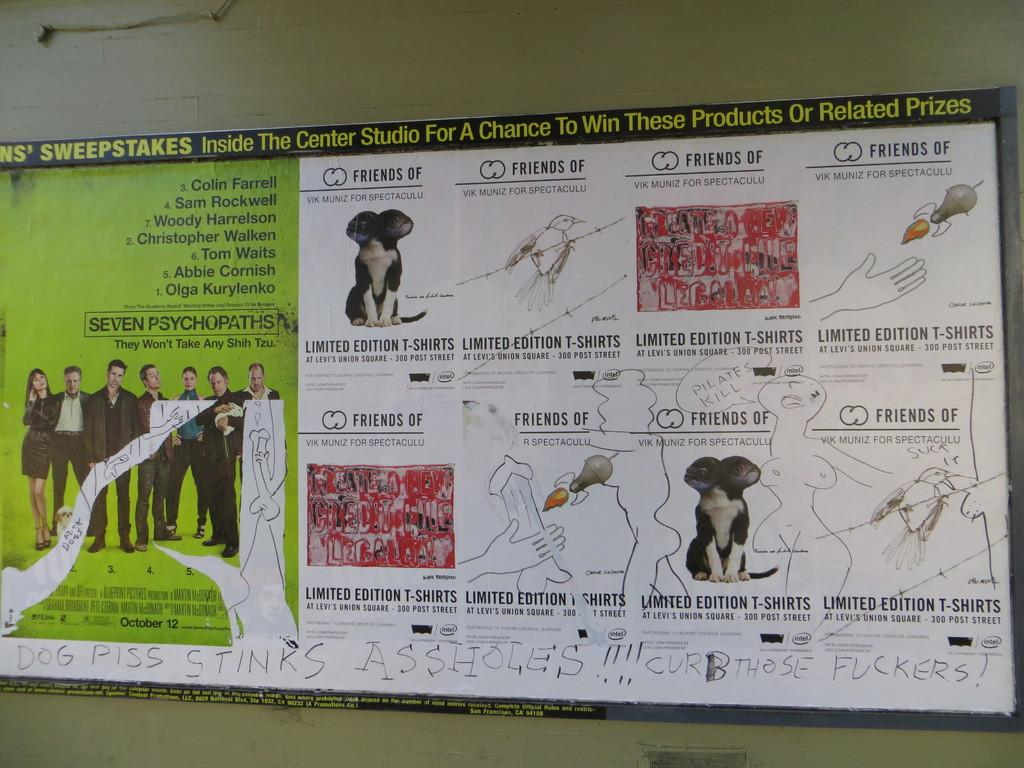Provide a one-sentence caption for the provided image. A sign for a movie called Seven Psychopaths has had graffiti written on it. 